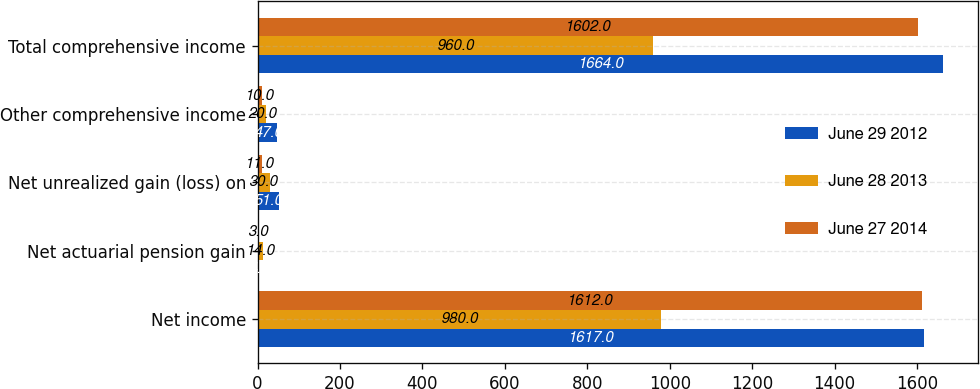Convert chart to OTSL. <chart><loc_0><loc_0><loc_500><loc_500><stacked_bar_chart><ecel><fcel>Net income<fcel>Net actuarial pension gain<fcel>Net unrealized gain (loss) on<fcel>Other comprehensive income<fcel>Total comprehensive income<nl><fcel>June 29 2012<fcel>1617<fcel>4<fcel>51<fcel>47<fcel>1664<nl><fcel>June 28 2013<fcel>980<fcel>14<fcel>30<fcel>20<fcel>960<nl><fcel>June 27 2014<fcel>1612<fcel>3<fcel>11<fcel>10<fcel>1602<nl></chart> 